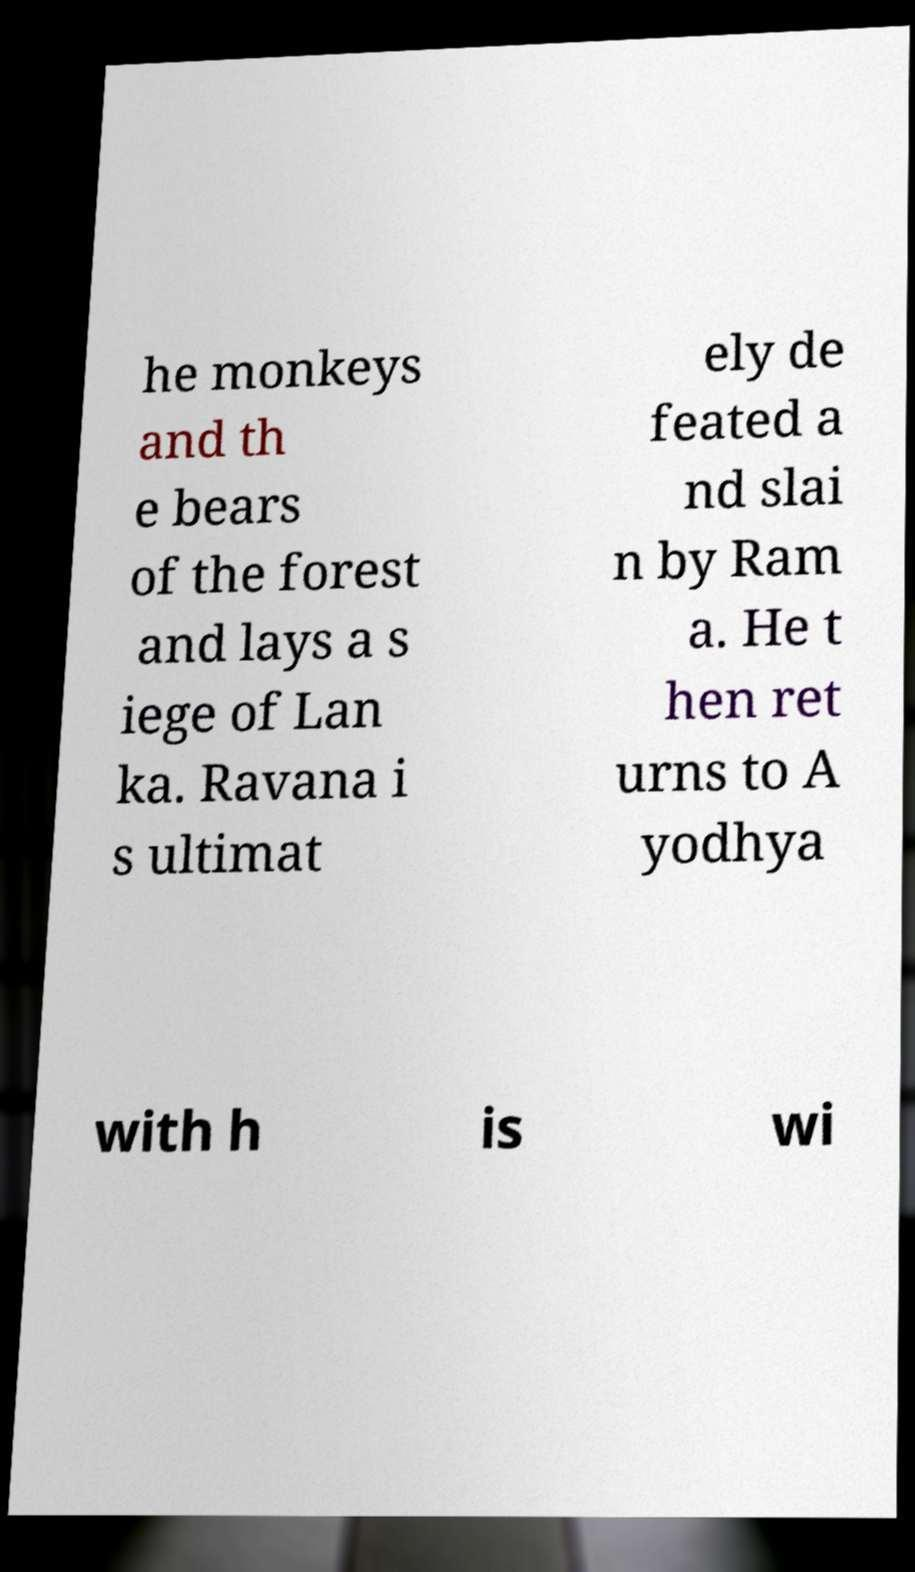Could you assist in decoding the text presented in this image and type it out clearly? he monkeys and th e bears of the forest and lays a s iege of Lan ka. Ravana i s ultimat ely de feated a nd slai n by Ram a. He t hen ret urns to A yodhya with h is wi 